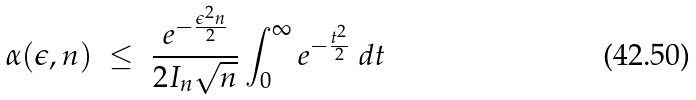Convert formula to latex. <formula><loc_0><loc_0><loc_500><loc_500>\alpha ( \epsilon , n ) \ \leq \ \frac { e ^ { - \frac { \epsilon ^ { 2 } n } { 2 } } } { 2 I _ { n } \sqrt { n } } \int _ { 0 } ^ { \infty } e ^ { - \frac { t ^ { 2 } } { 2 } } \ d t</formula> 